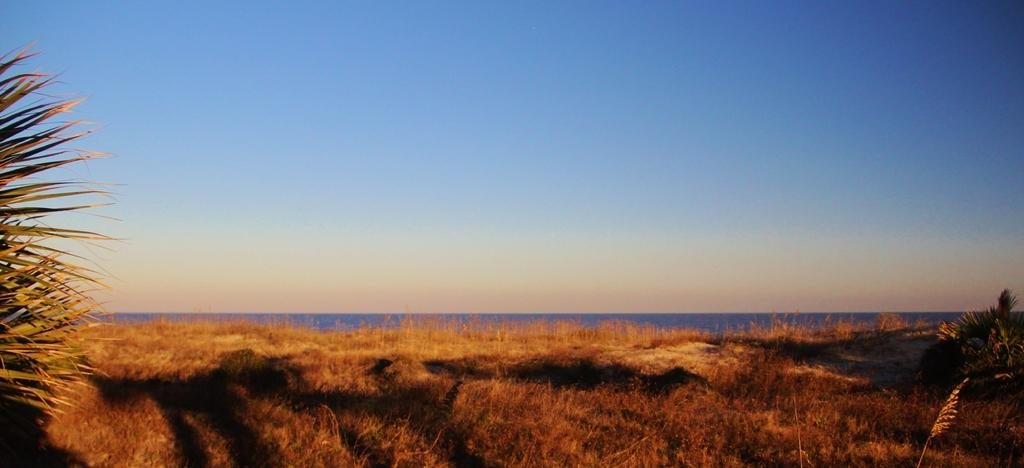What type of vegetation is at the bottom of the image? There is grass at the bottom of the image. What can be seen on the left side of the image? There are plants on the left side of the image. What is present on the right side of the image? There are plants on the right side of the image. What is visible in the background of the image? There appears to be water in the background of the image. What is visible at the top of the image? The sky is visible at the top of the image. Can you tell me how many giraffes are running in the image? There are no giraffes present in the image, and they are not running. What type of treatment is being administered to the plants in the image? There is no treatment being administered to the plants in the image; they are simply growing. 